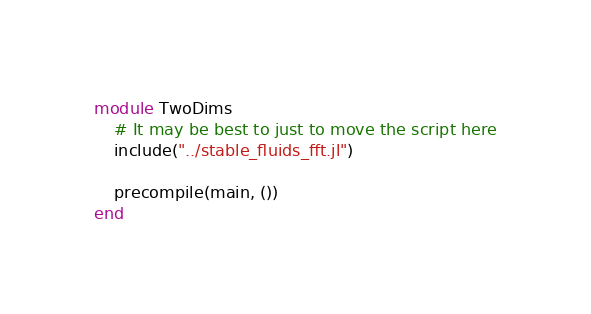<code> <loc_0><loc_0><loc_500><loc_500><_Julia_>module TwoDims
    # It may be best to just to move the script here
    include("../stable_fluids_fft.jl")

    precompile(main, ())
end</code> 